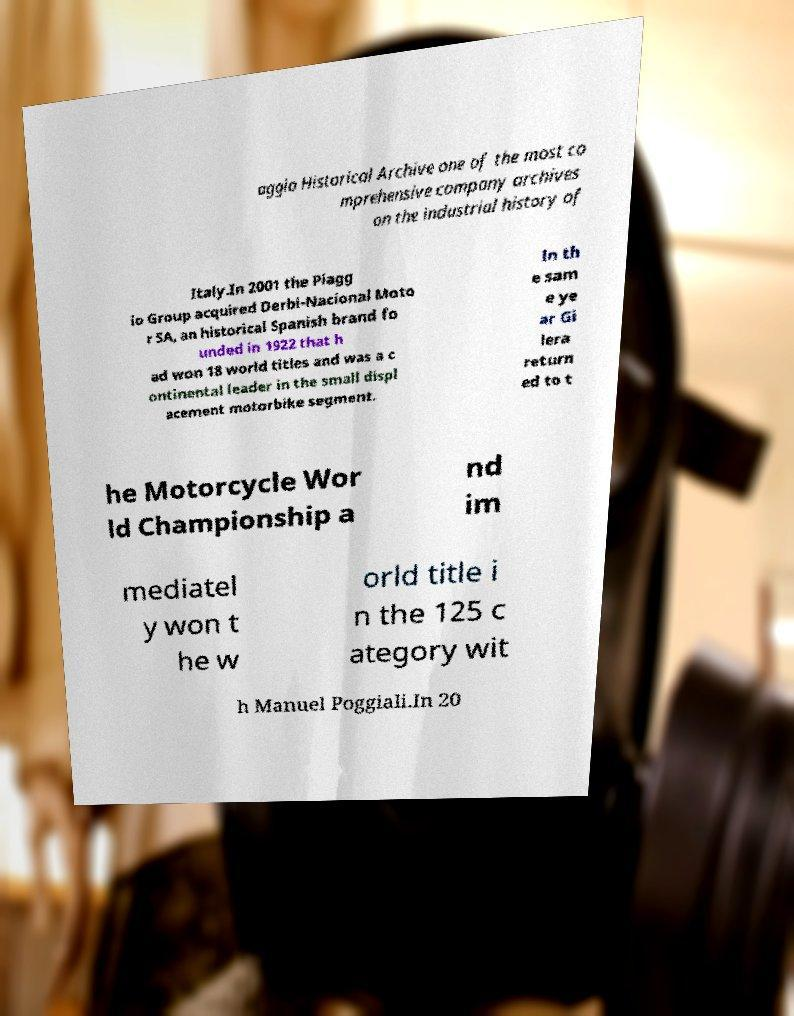Please identify and transcribe the text found in this image. aggio Historical Archive one of the most co mprehensive company archives on the industrial history of Italy.In 2001 the Piagg io Group acquired Derbi-Nacional Moto r SA, an historical Spanish brand fo unded in 1922 that h ad won 18 world titles and was a c ontinental leader in the small displ acement motorbike segment. In th e sam e ye ar Gi lera return ed to t he Motorcycle Wor ld Championship a nd im mediatel y won t he w orld title i n the 125 c ategory wit h Manuel Poggiali.In 20 